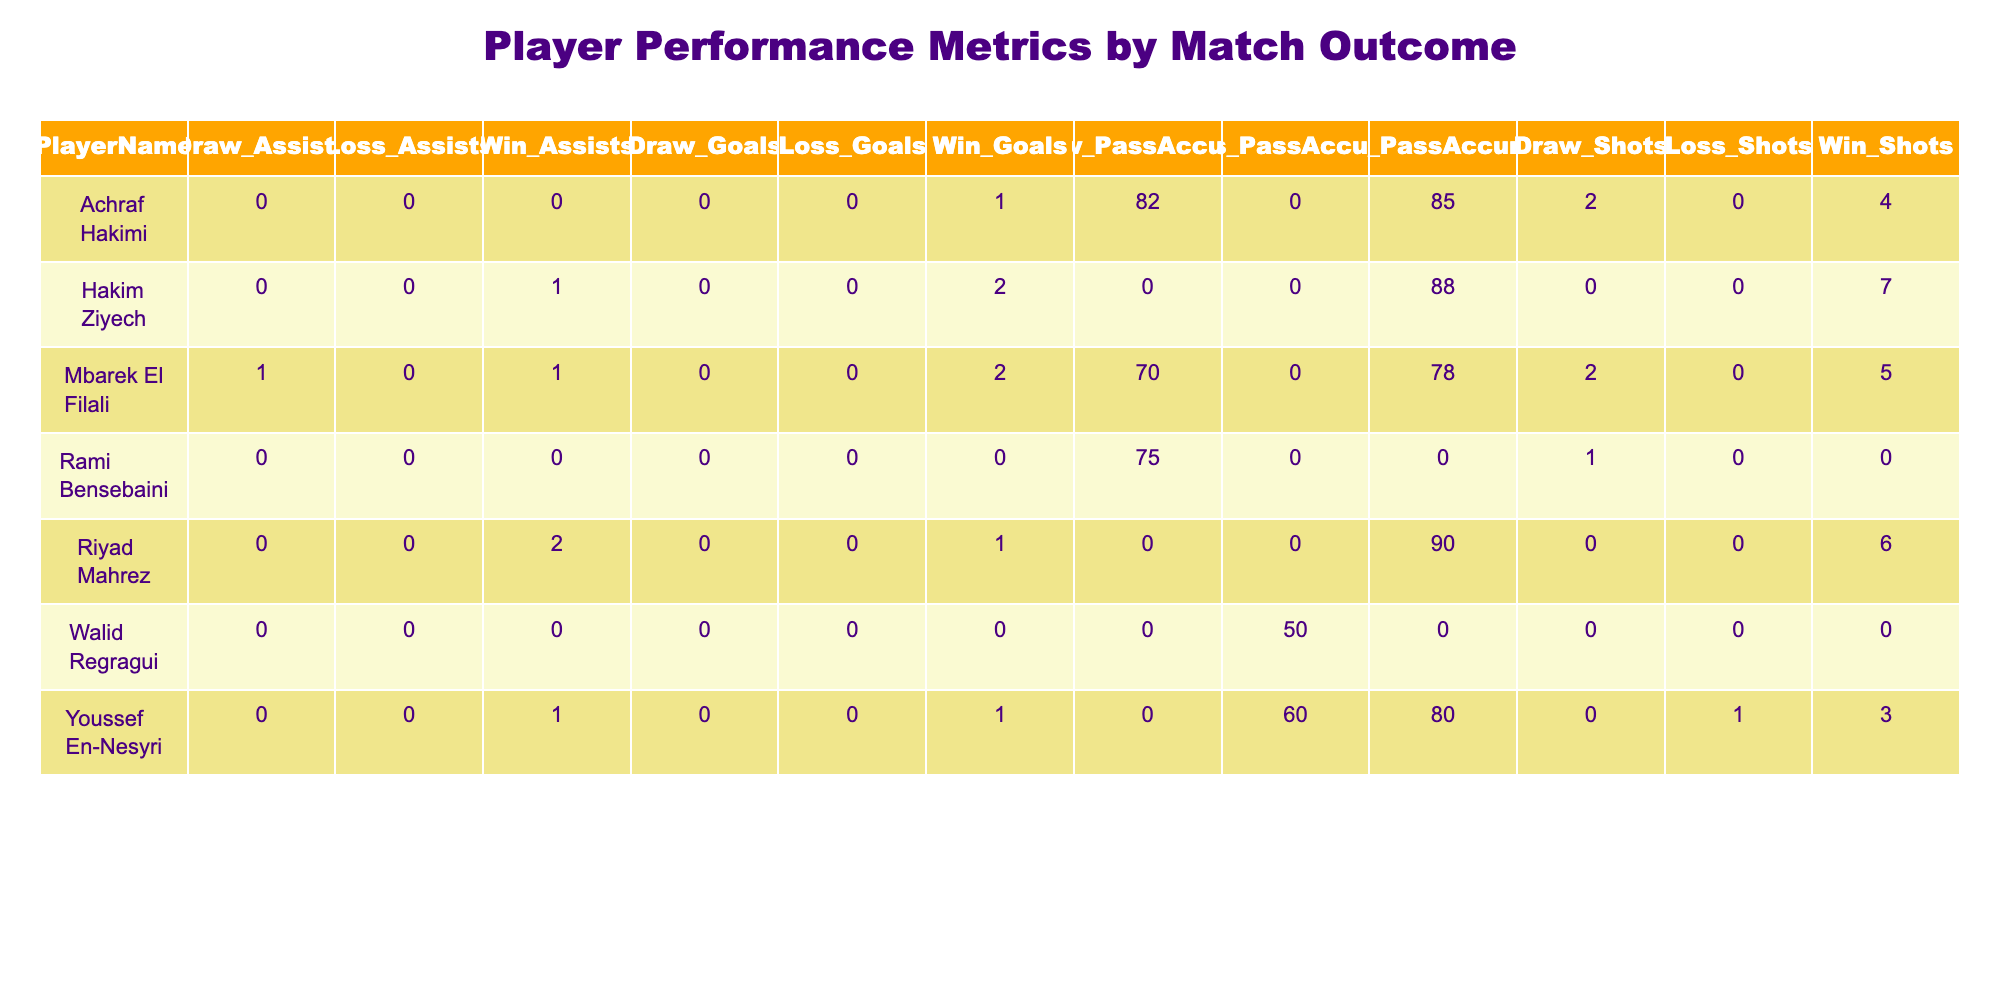What is the total number of goals scored by Mbarek El Filali? Mbarek El Filali has two recorded outcomes: in the win he scored 2 goals and in the draw, he scored 0 goals. Thus, to find the total goals scored, we add these values: 2 + 0 = 2.
Answer: 2 Which player had the highest pass accuracy in a winning match? In the winning matches, we look at the pass accuracy values for players: Mbarek El Filali (78), Achraf Hakimi (85), Youssef En-Nesyri (80), Riyad Mahrez (90), and Hakim Ziyech (88). The highest value among these is 90 belonging to Riyad Mahrez.
Answer: 90 Did Achraf Hakimi contribute any assists in matches that ended in a draw? In the draw matches for Achraf Hakimi, he recorded 0 assists. Therefore, he did not contribute any assists in those matches.
Answer: No How many shots did Youssef En-Nesyri attempt in total across all match outcomes? Youssef En-Nesyri had 3 shots in the win and 1 shot in the loss. In total, 3 + 1 = 4 shots were attempted.
Answer: 4 What is the average number of goals scored by players in matches that ended in a loss? The players who contributed in losses are Youssef En-Nesyri (0 goals) and Walid Regragui (0 goals), leading to a total of 0 goals for a total of 2 players. Therefore, the average would be 0 goals / 2 players = 0.
Answer: 0 What is the difference in total assists between winning and drawing matches for Mbarek El Filali? In winning matches, Mbarek El Filali has 1 assist, while in draws, he has 1 assist as well. The difference can be calculated as 1 - 1 = 0.
Answer: 0 How many players scored more than one goal in winning matches? In the win column, Mbarek El Filali scored 2 goals, Riyad Mahrez scored 1 goal, and Hakim Ziyech scored 2 goals. Therefore, there are 2 players (Mbarek El Filali and Hakim Ziyech) who scored more than one goal.
Answer: 2 Was there a player who did not record any assists in any match outcome? Checking the assist metrics for all players: Mbarek El Filali has 1, Achraf Hakimi has 0, Youssef En-Nesyri has 1, Riyad Mahrez has 2, Rami Bensebaini has 0, and Walid Regragui has 0. Thus, the players Achraf Hakimi, Rami Bensebaini, and Walid Regragui did not record any assists in any match outcome.
Answer: Yes What is the total number of shots taken by players in winning matches? The shots taken in winning matches are as follows: Mbarek El Filali (5), Achraf Hakimi (4), Youssef En-Nesyri (3), Riyad Mahrez (6), and Hakim Ziyech (7). Adding these gives 5 + 4 + 3 + 6 + 7 = 25 shots in total.
Answer: 25 